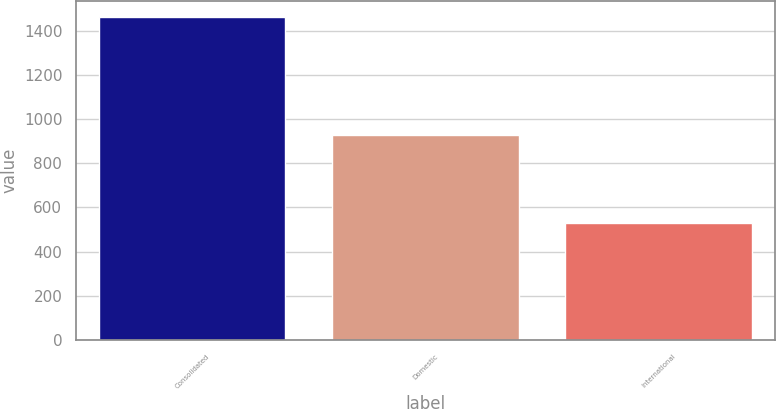<chart> <loc_0><loc_0><loc_500><loc_500><bar_chart><fcel>Consolidated<fcel>Domestic<fcel>International<nl><fcel>1460.8<fcel>929.2<fcel>531.6<nl></chart> 